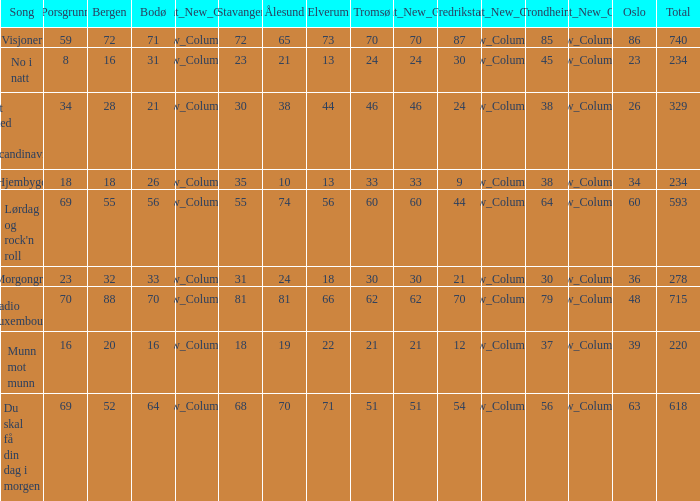When bergen reaches 88, what will be the alesund? 81.0. 